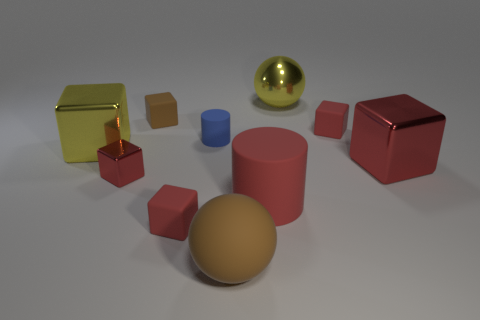How many red cubes must be subtracted to get 2 red cubes? 2 Subtract all red spheres. How many red cubes are left? 4 Subtract all brown cubes. How many cubes are left? 5 Subtract all tiny metal cubes. How many cubes are left? 5 Subtract all brown cubes. Subtract all red cylinders. How many cubes are left? 5 Subtract all cubes. How many objects are left? 4 Subtract 0 yellow cylinders. How many objects are left? 10 Subtract all blue metal objects. Subtract all big brown spheres. How many objects are left? 9 Add 2 large red cubes. How many large red cubes are left? 3 Add 5 large brown balls. How many large brown balls exist? 6 